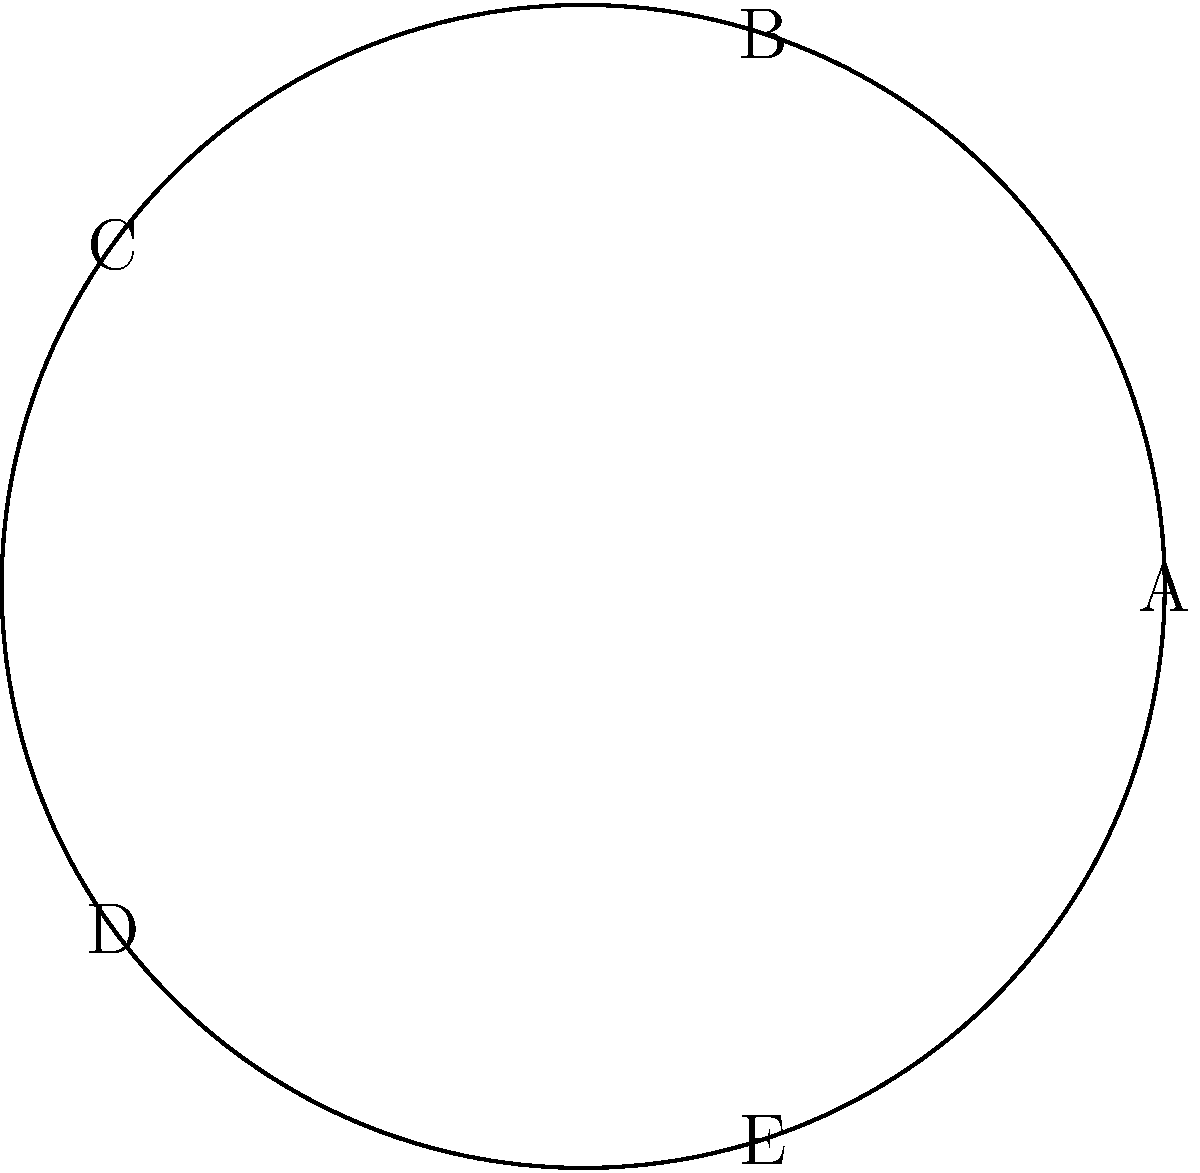Consider the pentagram, a common symbol in literature often associated with magic and the occult. What is the order of the symmetry group for this literary motif, and how many rotational and reflectional symmetries does it possess? To determine the symmetry group of the pentagram, we need to consider both rotational and reflectional symmetries:

1. Rotational symmetries:
   - The pentagram has 5-fold rotational symmetry.
   - It can be rotated by 72°, 144°, 216°, 288°, and 360° (0°) to map onto itself.
   - This gives 5 rotational symmetries, including the identity rotation.

2. Reflectional symmetries:
   - The pentagram has 5 lines of reflection, each passing through a vertex and the midpoint of the opposite side.
   - These reflections correspond to the 5 mirror lines of symmetry.

3. Calculating the order of the symmetry group:
   - The total number of symmetries is the sum of rotational and reflectional symmetries.
   - Order of the symmetry group = 5 (rotations) + 5 (reflections) = 10

4. Identifying the symmetry group:
   - The symmetry group of the pentagram is the dihedral group $D_5$.
   - $D_5$ has order 10 and includes 5 rotations and 5 reflections.

Therefore, the pentagram has a symmetry group of order 10, with 5 rotational symmetries and 5 reflectional symmetries.
Answer: Order: 10; 5 rotational, 5 reflectional symmetries 